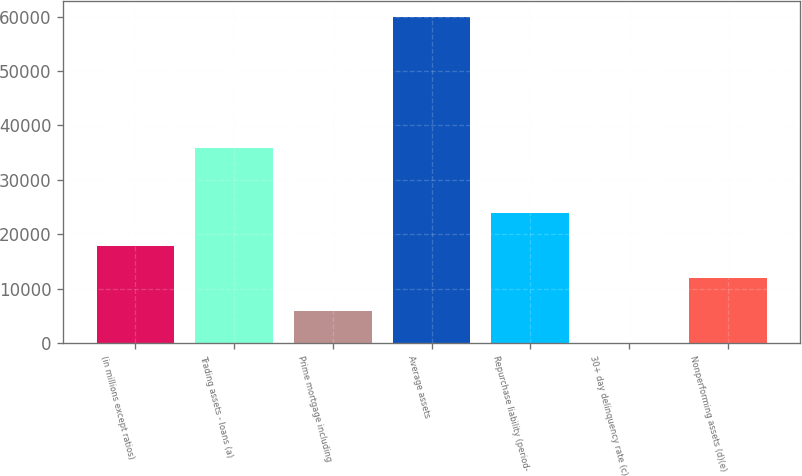Convert chart to OTSL. <chart><loc_0><loc_0><loc_500><loc_500><bar_chart><fcel>(in millions except ratios)<fcel>Trading assets - loans (a)<fcel>Prime mortgage including<fcel>Average assets<fcel>Repurchase liability (period-<fcel>30+ day delinquency rate (c)<fcel>Nonperforming assets (d)(e)<nl><fcel>17953.2<fcel>35903.4<fcel>5986.45<fcel>59837<fcel>23936.7<fcel>3.05<fcel>11969.9<nl></chart> 